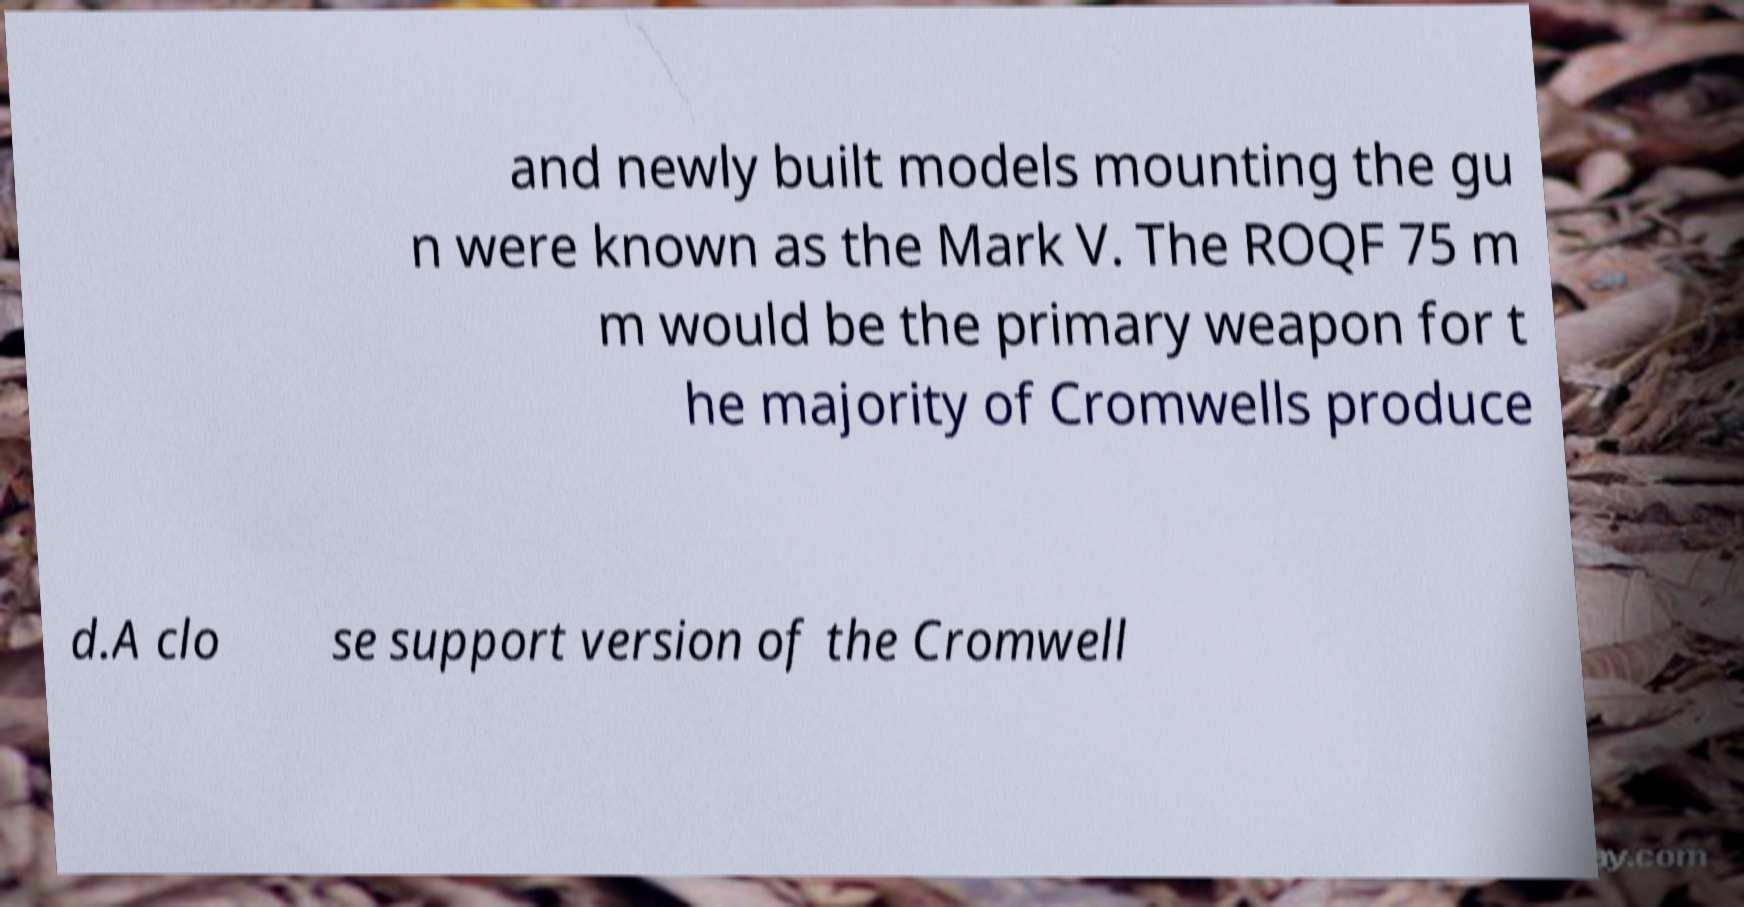Can you accurately transcribe the text from the provided image for me? and newly built models mounting the gu n were known as the Mark V. The ROQF 75 m m would be the primary weapon for t he majority of Cromwells produce d.A clo se support version of the Cromwell 